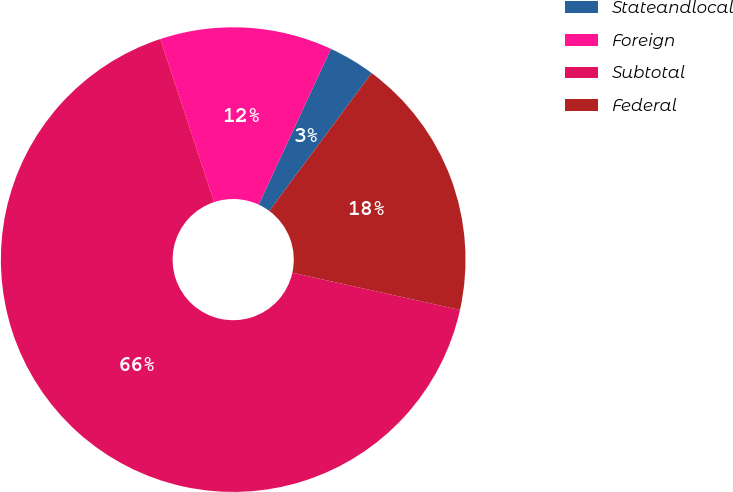Convert chart. <chart><loc_0><loc_0><loc_500><loc_500><pie_chart><fcel>Stateandlocal<fcel>Foreign<fcel>Subtotal<fcel>Federal<nl><fcel>3.25%<fcel>11.99%<fcel>66.45%<fcel>18.31%<nl></chart> 